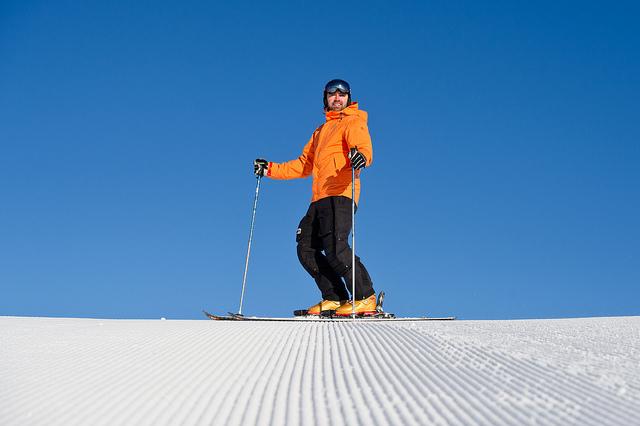Where are the trees?
Short answer required. Nowhere. What color is the Man's Jacket?
Answer briefly. Orange. What is the man riding on?
Concise answer only. Skis. What color is this person's outfit?
Answer briefly. Orange. Is the man in the center of the picture?
Keep it brief. Yes. Is the snow exactly as it fell?
Give a very brief answer. No. 